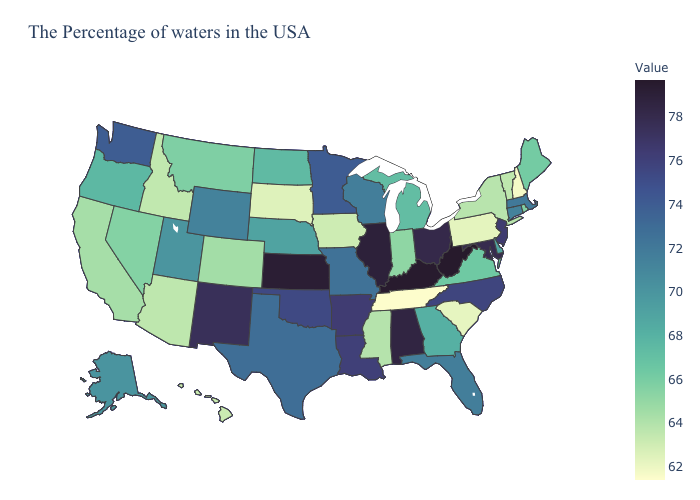Does Arizona have the lowest value in the West?
Concise answer only. No. Which states hav the highest value in the Northeast?
Write a very short answer. New Jersey. Does the map have missing data?
Keep it brief. No. Does Alaska have a lower value than South Dakota?
Quick response, please. No. Does New York have a higher value than New Hampshire?
Write a very short answer. Yes. Does Rhode Island have a higher value than Nebraska?
Be succinct. No. Does Hawaii have the highest value in the West?
Concise answer only. No. 